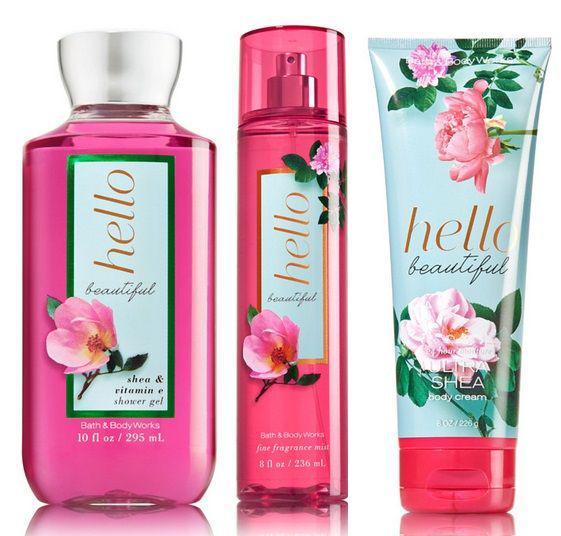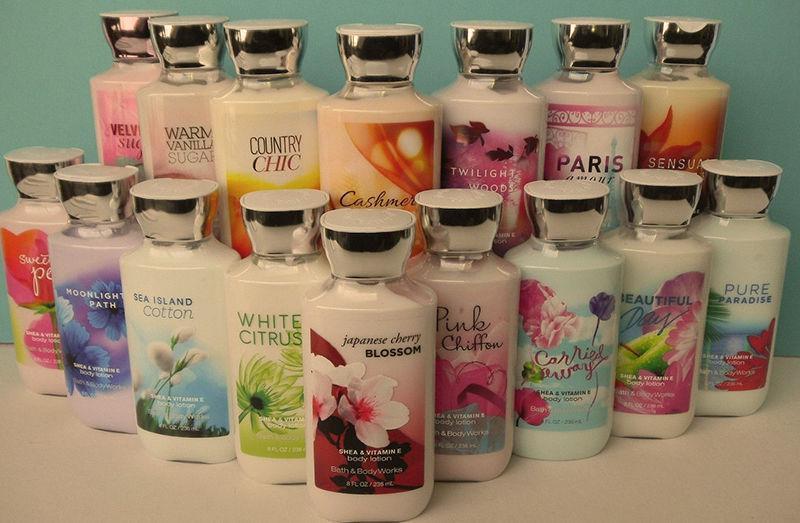The first image is the image on the left, the second image is the image on the right. Evaluate the accuracy of this statement regarding the images: "One of the images has exactly three bottles.". Is it true? Answer yes or no. Yes. The first image is the image on the left, the second image is the image on the right. Considering the images on both sides, is "There are exactly three products in one of the images." valid? Answer yes or no. Yes. 